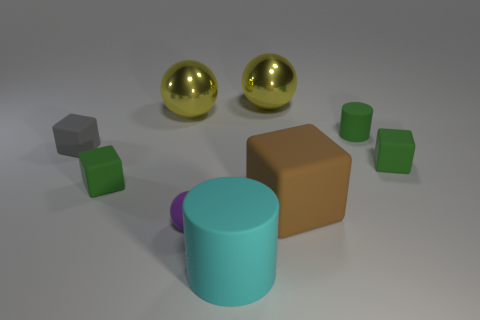Subtract all small rubber cubes. How many cubes are left? 1 Subtract all blocks. How many objects are left? 5 Subtract 2 cubes. How many cubes are left? 2 Subtract 0 cyan blocks. How many objects are left? 9 Subtract all green cubes. Subtract all gray balls. How many cubes are left? 2 Subtract all blue spheres. How many gray blocks are left? 1 Subtract all big green metal blocks. Subtract all gray cubes. How many objects are left? 8 Add 9 small cylinders. How many small cylinders are left? 10 Add 4 purple matte balls. How many purple matte balls exist? 5 Add 1 big cyan rubber things. How many objects exist? 10 